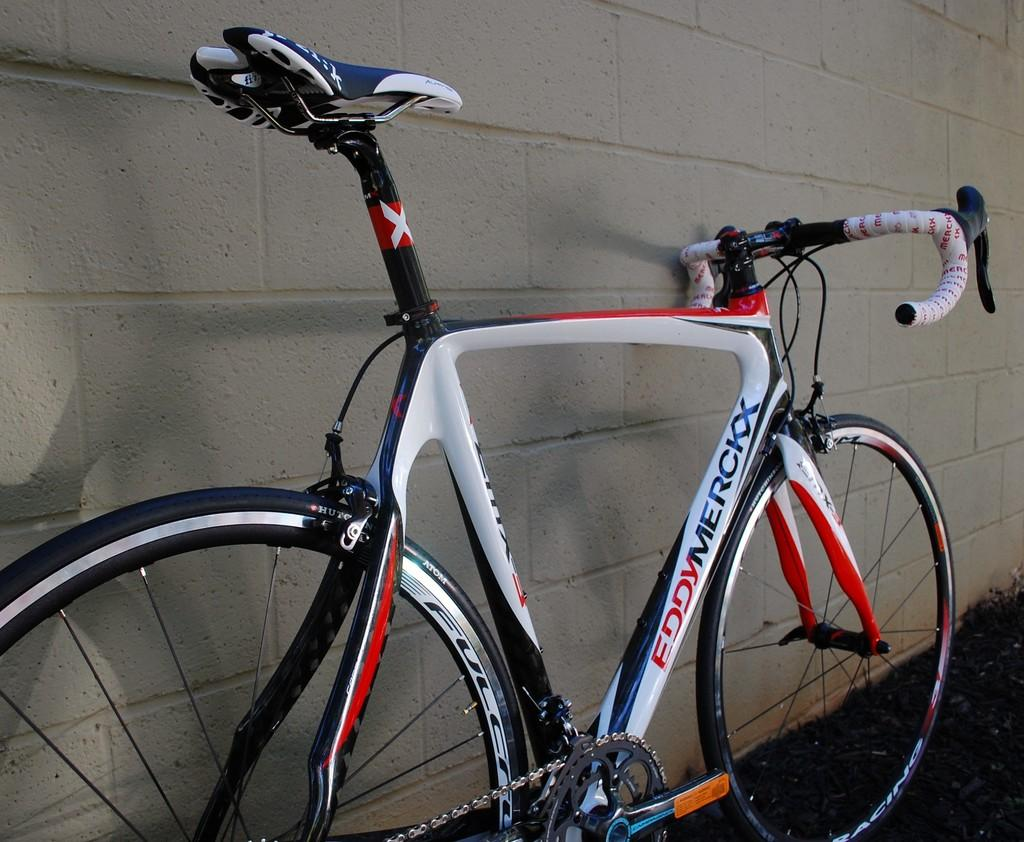What is the main subject in the image? There is a cycle in the image. How is the cycle positioned in relation to other elements in the image? The cycle is in front of other elements in the image. What can be seen behind the cycle? There is a wall behind the cycle. How many twigs are being rubbed together by the coach in the image? There are no twigs, rubbing, or coach present in the image. 